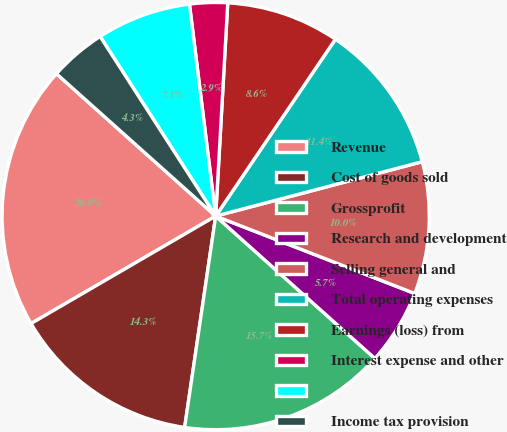Convert chart to OTSL. <chart><loc_0><loc_0><loc_500><loc_500><pie_chart><fcel>Revenue<fcel>Cost of goods sold<fcel>Grossprofit<fcel>Research and development<fcel>Selling general and<fcel>Total operating expenses<fcel>Earnings (loss) from<fcel>Interest expense and other<fcel>Unnamed: 8<fcel>Income tax provision<nl><fcel>20.0%<fcel>14.29%<fcel>15.71%<fcel>5.71%<fcel>10.0%<fcel>11.43%<fcel>8.57%<fcel>2.86%<fcel>7.14%<fcel>4.29%<nl></chart> 